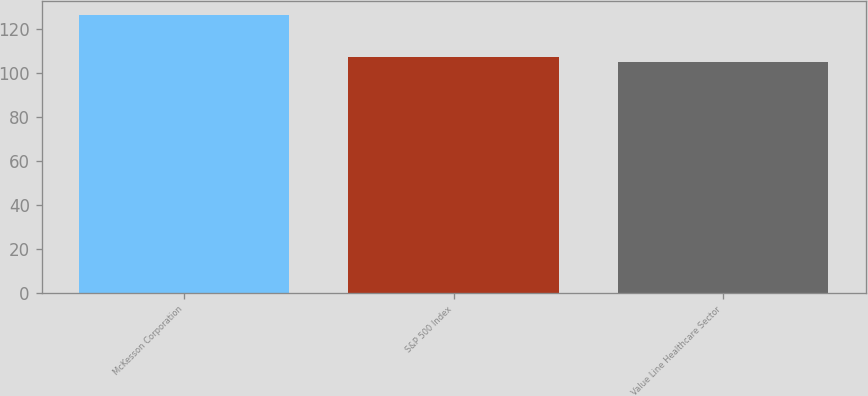Convert chart to OTSL. <chart><loc_0><loc_0><loc_500><loc_500><bar_chart><fcel>McKesson Corporation<fcel>S&P 500 Index<fcel>Value Line Healthcare Sector<nl><fcel>126.38<fcel>107.24<fcel>105.11<nl></chart> 